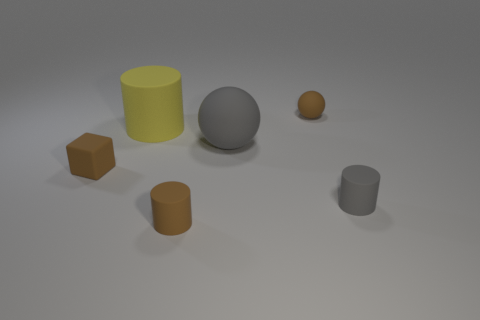What size is the brown rubber thing that is the same shape as the large gray thing?
Your answer should be compact. Small. Are there any other objects that have the same shape as the yellow rubber object?
Your answer should be very brief. Yes. How many red rubber blocks have the same size as the brown rubber cylinder?
Keep it short and to the point. 0. Do the sphere behind the big matte sphere and the cylinder that is behind the big gray object have the same size?
Your response must be concise. No. There is a sphere in front of the big matte cylinder; what is its size?
Provide a succinct answer. Large. What is the size of the cylinder that is behind the gray object to the left of the small brown matte sphere?
Your response must be concise. Large. There is a sphere that is the same size as the yellow rubber cylinder; what is its material?
Make the answer very short. Rubber. There is a gray cylinder; are there any matte objects to the left of it?
Your response must be concise. Yes. Are there an equal number of big yellow cylinders that are in front of the big gray matte sphere and large purple rubber cubes?
Give a very brief answer. Yes. There is a thing that is the same size as the yellow rubber cylinder; what is its shape?
Ensure brevity in your answer.  Sphere. 